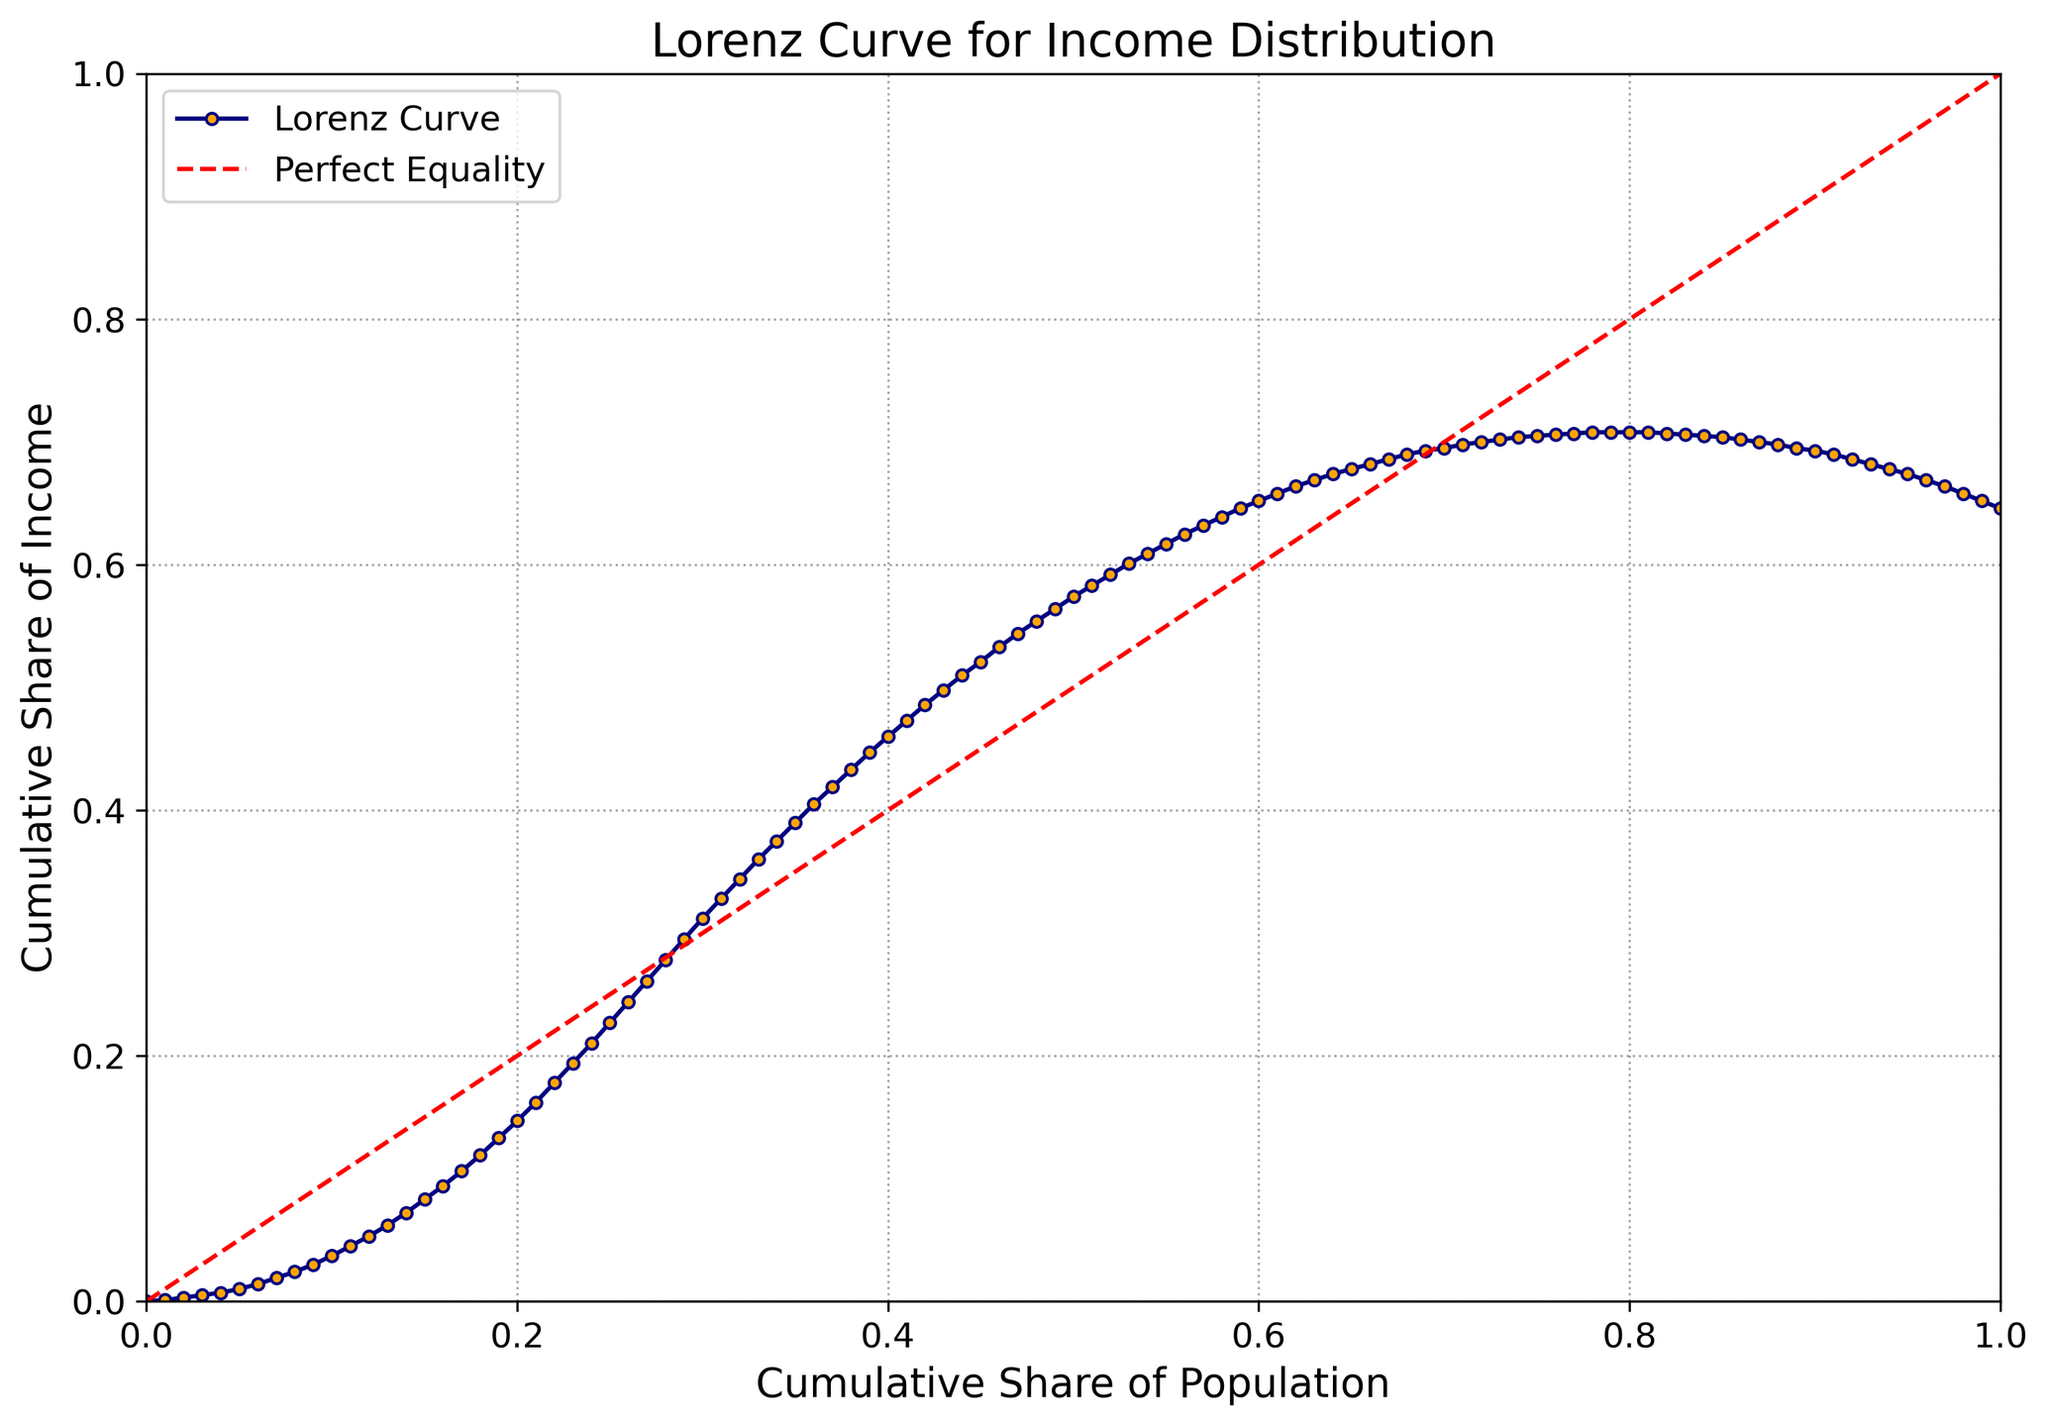What does the Lorenz Curve represent in the figure? The Lorenz Curve represents the distribution of income across different quantiles of the population. It shows the cumulative share of income received by the cumulative share of the population, starting from the lowest quantile to the highest.
Answer: Income distribution How does the Lorenz Curve compare to the line of perfect equality in the figure? The Lorenz Curve lies below the line of perfect equality, indicating income inequality. The farther the Lorenz Curve is from the line of perfect equality, the greater the inequality.
Answer: Below and farther At what quantile does the cumulative share of income reach approximately 50%? Based on the Lorenz Curve, the cumulative share of income reaches approximately 50% at around the 75th quantile.
Answer: 0.75 What does the red dashed line in the figure represent? The red dashed line represents the line of perfect equality, where each quantile of the population would have the same cumulative share of income.
Answer: Line of perfect equality How does the income share differ between the 30th quantile and the 60th quantile? At the 30th quantile, the cumulative share of income is approximately 31.2%, while at the 60th quantile, it is approximately 65.2%. The difference is 65.2% - 31.2% = 34%.
Answer: 34% What is the cumulative share of income for the top 10% of the population? The cumulative share of income for the top 10% of the population can be found at the 90th quantile. The Lorenz Curve shows that it is approximately 69.3%.
Answer: 69.3% By what percentage does the cumulative income share of the 50th quantile differ from the perfect equality line? Under perfect equality, the 50th quantile would have 50% of the income. The Lorenz Curve shows that at the 50th quantile, the cumulative share of income is approximately 57.4%, which is a difference of 57.4% - 50% = 7.4%.
Answer: 7.4% What kind of trend is observed in the Lorenz Curve as we move from the lower quantiles to the higher quantiles? As we move from the lower quantiles to the higher quantiles, the Lorenz Curve initially rises slowly and then rises more steeply, indicating that income is more evenly distributed among the higher quantiles.
Answer: Rising trend At which quantile does the cumulative income share begin to show a noticeable increase? The noticeable increase in cumulative income share begins around the 20th quantile, where the curve starts to become steeper.
Answer: 0.20 How does the presence of grid lines in the figure aid in understanding the Lorenz Curve? The grid lines enhance readability by helping to visualize and accurately interpret the values and relationships in the Lorenz Curve, such as the exact cumulative shares of income at different quantiles.
Answer: Enhance readability 